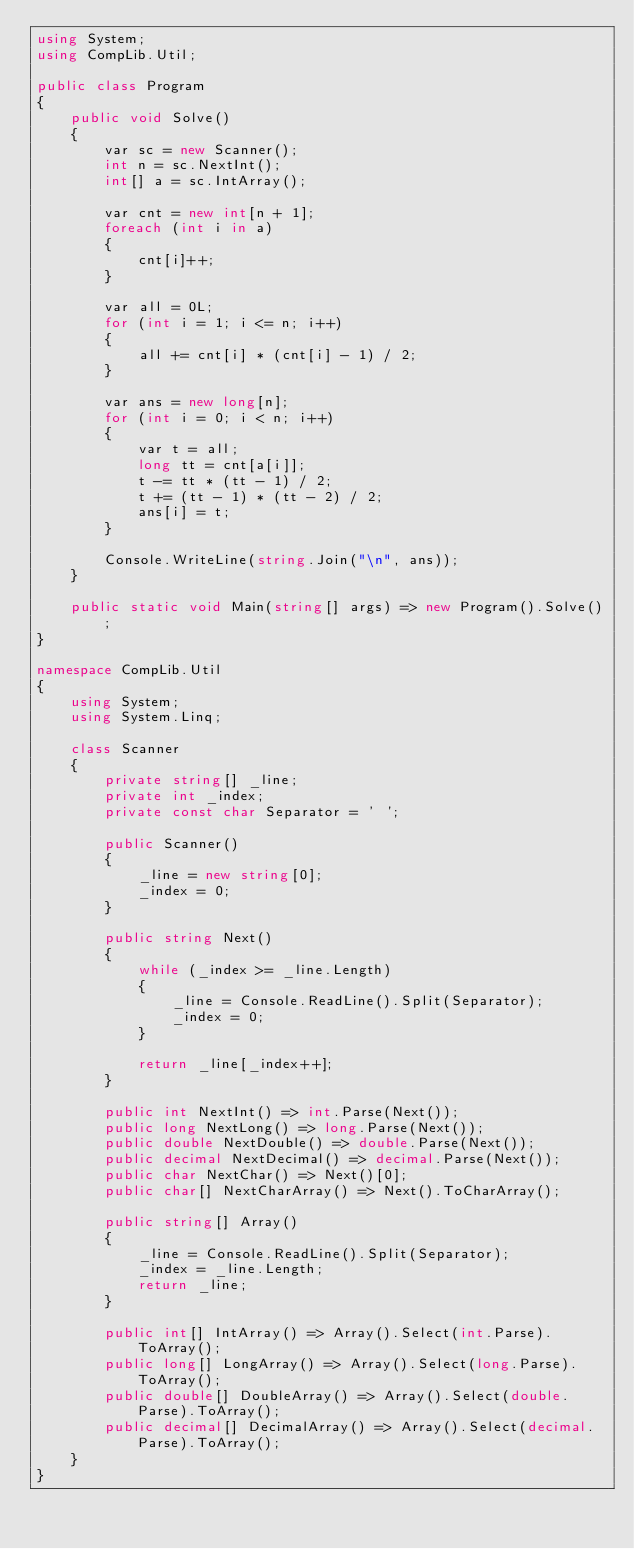Convert code to text. <code><loc_0><loc_0><loc_500><loc_500><_C#_>using System;
using CompLib.Util;

public class Program
{
    public void Solve()
    {
        var sc = new Scanner();
        int n = sc.NextInt();
        int[] a = sc.IntArray();

        var cnt = new int[n + 1];
        foreach (int i in a)
        {
            cnt[i]++;
        }

        var all = 0L;
        for (int i = 1; i <= n; i++)
        {
            all += cnt[i] * (cnt[i] - 1) / 2;
        }

        var ans = new long[n];
        for (int i = 0; i < n; i++)
        {
            var t = all;
            long tt = cnt[a[i]];
            t -= tt * (tt - 1) / 2;
            t += (tt - 1) * (tt - 2) / 2;
            ans[i] = t;
        }

        Console.WriteLine(string.Join("\n", ans));
    }

    public static void Main(string[] args) => new Program().Solve();
}

namespace CompLib.Util
{
    using System;
    using System.Linq;

    class Scanner
    {
        private string[] _line;
        private int _index;
        private const char Separator = ' ';

        public Scanner()
        {
            _line = new string[0];
            _index = 0;
        }

        public string Next()
        {
            while (_index >= _line.Length)
            {
                _line = Console.ReadLine().Split(Separator);
                _index = 0;
            }

            return _line[_index++];
        }

        public int NextInt() => int.Parse(Next());
        public long NextLong() => long.Parse(Next());
        public double NextDouble() => double.Parse(Next());
        public decimal NextDecimal() => decimal.Parse(Next());
        public char NextChar() => Next()[0];
        public char[] NextCharArray() => Next().ToCharArray();

        public string[] Array()
        {
            _line = Console.ReadLine().Split(Separator);
            _index = _line.Length;
            return _line;
        }

        public int[] IntArray() => Array().Select(int.Parse).ToArray();
        public long[] LongArray() => Array().Select(long.Parse).ToArray();
        public double[] DoubleArray() => Array().Select(double.Parse).ToArray();
        public decimal[] DecimalArray() => Array().Select(decimal.Parse).ToArray();
    }
}</code> 